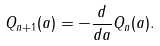Convert formula to latex. <formula><loc_0><loc_0><loc_500><loc_500>Q _ { n + 1 } ( a ) = - \frac { d } { d a } Q _ { n } ( a ) .</formula> 